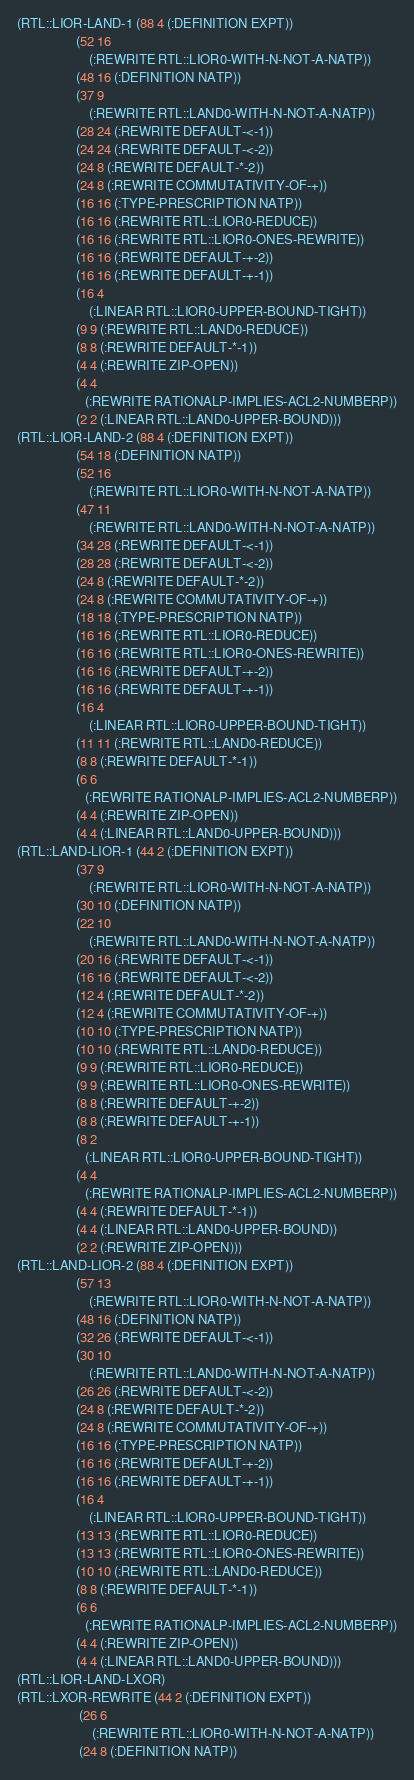<code> <loc_0><loc_0><loc_500><loc_500><_Lisp_>(RTL::LIOR-LAND-1 (88 4 (:DEFINITION EXPT))
                  (52 16
                      (:REWRITE RTL::LIOR0-WITH-N-NOT-A-NATP))
                  (48 16 (:DEFINITION NATP))
                  (37 9
                      (:REWRITE RTL::LAND0-WITH-N-NOT-A-NATP))
                  (28 24 (:REWRITE DEFAULT-<-1))
                  (24 24 (:REWRITE DEFAULT-<-2))
                  (24 8 (:REWRITE DEFAULT-*-2))
                  (24 8 (:REWRITE COMMUTATIVITY-OF-+))
                  (16 16 (:TYPE-PRESCRIPTION NATP))
                  (16 16 (:REWRITE RTL::LIOR0-REDUCE))
                  (16 16 (:REWRITE RTL::LIOR0-ONES-REWRITE))
                  (16 16 (:REWRITE DEFAULT-+-2))
                  (16 16 (:REWRITE DEFAULT-+-1))
                  (16 4
                      (:LINEAR RTL::LIOR0-UPPER-BOUND-TIGHT))
                  (9 9 (:REWRITE RTL::LAND0-REDUCE))
                  (8 8 (:REWRITE DEFAULT-*-1))
                  (4 4 (:REWRITE ZIP-OPEN))
                  (4 4
                     (:REWRITE RATIONALP-IMPLIES-ACL2-NUMBERP))
                  (2 2 (:LINEAR RTL::LAND0-UPPER-BOUND)))
(RTL::LIOR-LAND-2 (88 4 (:DEFINITION EXPT))
                  (54 18 (:DEFINITION NATP))
                  (52 16
                      (:REWRITE RTL::LIOR0-WITH-N-NOT-A-NATP))
                  (47 11
                      (:REWRITE RTL::LAND0-WITH-N-NOT-A-NATP))
                  (34 28 (:REWRITE DEFAULT-<-1))
                  (28 28 (:REWRITE DEFAULT-<-2))
                  (24 8 (:REWRITE DEFAULT-*-2))
                  (24 8 (:REWRITE COMMUTATIVITY-OF-+))
                  (18 18 (:TYPE-PRESCRIPTION NATP))
                  (16 16 (:REWRITE RTL::LIOR0-REDUCE))
                  (16 16 (:REWRITE RTL::LIOR0-ONES-REWRITE))
                  (16 16 (:REWRITE DEFAULT-+-2))
                  (16 16 (:REWRITE DEFAULT-+-1))
                  (16 4
                      (:LINEAR RTL::LIOR0-UPPER-BOUND-TIGHT))
                  (11 11 (:REWRITE RTL::LAND0-REDUCE))
                  (8 8 (:REWRITE DEFAULT-*-1))
                  (6 6
                     (:REWRITE RATIONALP-IMPLIES-ACL2-NUMBERP))
                  (4 4 (:REWRITE ZIP-OPEN))
                  (4 4 (:LINEAR RTL::LAND0-UPPER-BOUND)))
(RTL::LAND-LIOR-1 (44 2 (:DEFINITION EXPT))
                  (37 9
                      (:REWRITE RTL::LIOR0-WITH-N-NOT-A-NATP))
                  (30 10 (:DEFINITION NATP))
                  (22 10
                      (:REWRITE RTL::LAND0-WITH-N-NOT-A-NATP))
                  (20 16 (:REWRITE DEFAULT-<-1))
                  (16 16 (:REWRITE DEFAULT-<-2))
                  (12 4 (:REWRITE DEFAULT-*-2))
                  (12 4 (:REWRITE COMMUTATIVITY-OF-+))
                  (10 10 (:TYPE-PRESCRIPTION NATP))
                  (10 10 (:REWRITE RTL::LAND0-REDUCE))
                  (9 9 (:REWRITE RTL::LIOR0-REDUCE))
                  (9 9 (:REWRITE RTL::LIOR0-ONES-REWRITE))
                  (8 8 (:REWRITE DEFAULT-+-2))
                  (8 8 (:REWRITE DEFAULT-+-1))
                  (8 2
                     (:LINEAR RTL::LIOR0-UPPER-BOUND-TIGHT))
                  (4 4
                     (:REWRITE RATIONALP-IMPLIES-ACL2-NUMBERP))
                  (4 4 (:REWRITE DEFAULT-*-1))
                  (4 4 (:LINEAR RTL::LAND0-UPPER-BOUND))
                  (2 2 (:REWRITE ZIP-OPEN)))
(RTL::LAND-LIOR-2 (88 4 (:DEFINITION EXPT))
                  (57 13
                      (:REWRITE RTL::LIOR0-WITH-N-NOT-A-NATP))
                  (48 16 (:DEFINITION NATP))
                  (32 26 (:REWRITE DEFAULT-<-1))
                  (30 10
                      (:REWRITE RTL::LAND0-WITH-N-NOT-A-NATP))
                  (26 26 (:REWRITE DEFAULT-<-2))
                  (24 8 (:REWRITE DEFAULT-*-2))
                  (24 8 (:REWRITE COMMUTATIVITY-OF-+))
                  (16 16 (:TYPE-PRESCRIPTION NATP))
                  (16 16 (:REWRITE DEFAULT-+-2))
                  (16 16 (:REWRITE DEFAULT-+-1))
                  (16 4
                      (:LINEAR RTL::LIOR0-UPPER-BOUND-TIGHT))
                  (13 13 (:REWRITE RTL::LIOR0-REDUCE))
                  (13 13 (:REWRITE RTL::LIOR0-ONES-REWRITE))
                  (10 10 (:REWRITE RTL::LAND0-REDUCE))
                  (8 8 (:REWRITE DEFAULT-*-1))
                  (6 6
                     (:REWRITE RATIONALP-IMPLIES-ACL2-NUMBERP))
                  (4 4 (:REWRITE ZIP-OPEN))
                  (4 4 (:LINEAR RTL::LAND0-UPPER-BOUND)))
(RTL::LIOR-LAND-LXOR)
(RTL::LXOR-REWRITE (44 2 (:DEFINITION EXPT))
                   (26 6
                       (:REWRITE RTL::LIOR0-WITH-N-NOT-A-NATP))
                   (24 8 (:DEFINITION NATP))</code> 